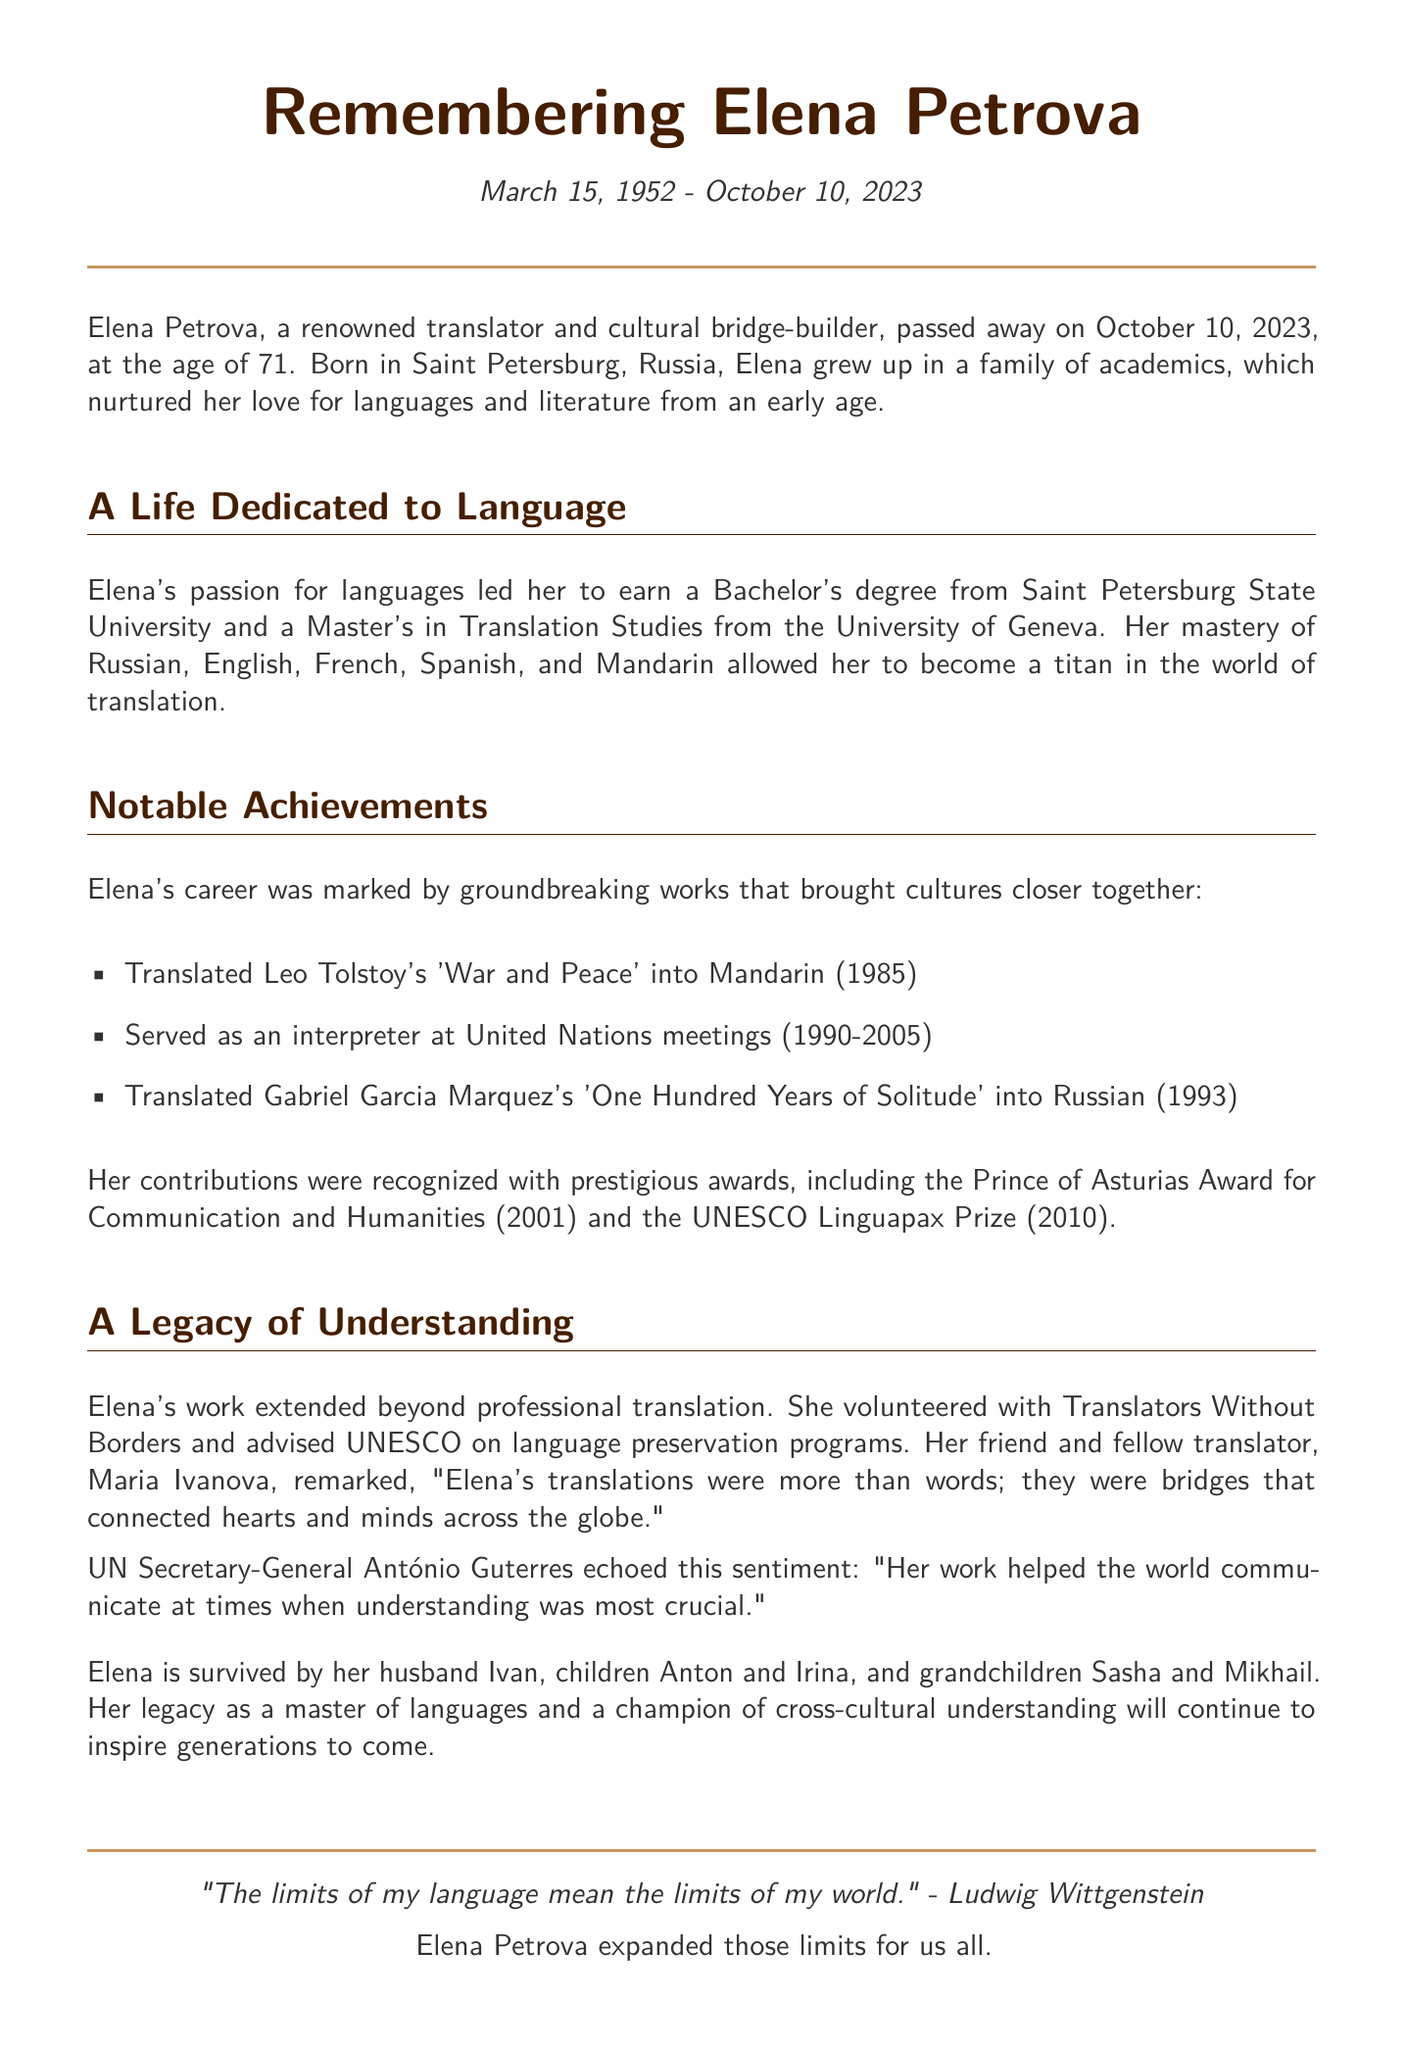What was Elena Petrova's date of birth? The document states that Elena Petrova was born on March 15, 1952.
Answer: March 15, 1952 In what city was Elena Petrova born? The obituary mentions that she was born in Saint Petersburg, Russia.
Answer: Saint Petersburg, Russia What degree did Elena earn from Saint Petersburg State University? It states that she earned a Bachelor's degree from there.
Answer: Bachelor's degree Which award did Elena receive in 2001? The document lists the Prince of Asturias Award for Communication and Humanities as an award she received in that year.
Answer: Prince of Asturias Award How many languages could Elena Petrova translate? The text indicates that she mastered five languages.
Answer: Five What organization did Elena volunteer for? The obituary notes that she volunteered with Translators Without Borders.
Answer: Translators Without Borders What was Elena's profession? The document identifies her as a renowned translator.
Answer: Translator What did UN Secretary-General António Guterres say about Elena? He commented that her work helped the world communicate when understanding was most crucial.
Answer: Her work helped the world communicate at times when understanding was most crucial Who survived Elena Petrova? The document lists her husband Ivan, children Anton and Irina, and grandchildren Sasha and Mikhail as survivors.
Answer: Ivan, Anton, Irina, Sasha, Mikhail 